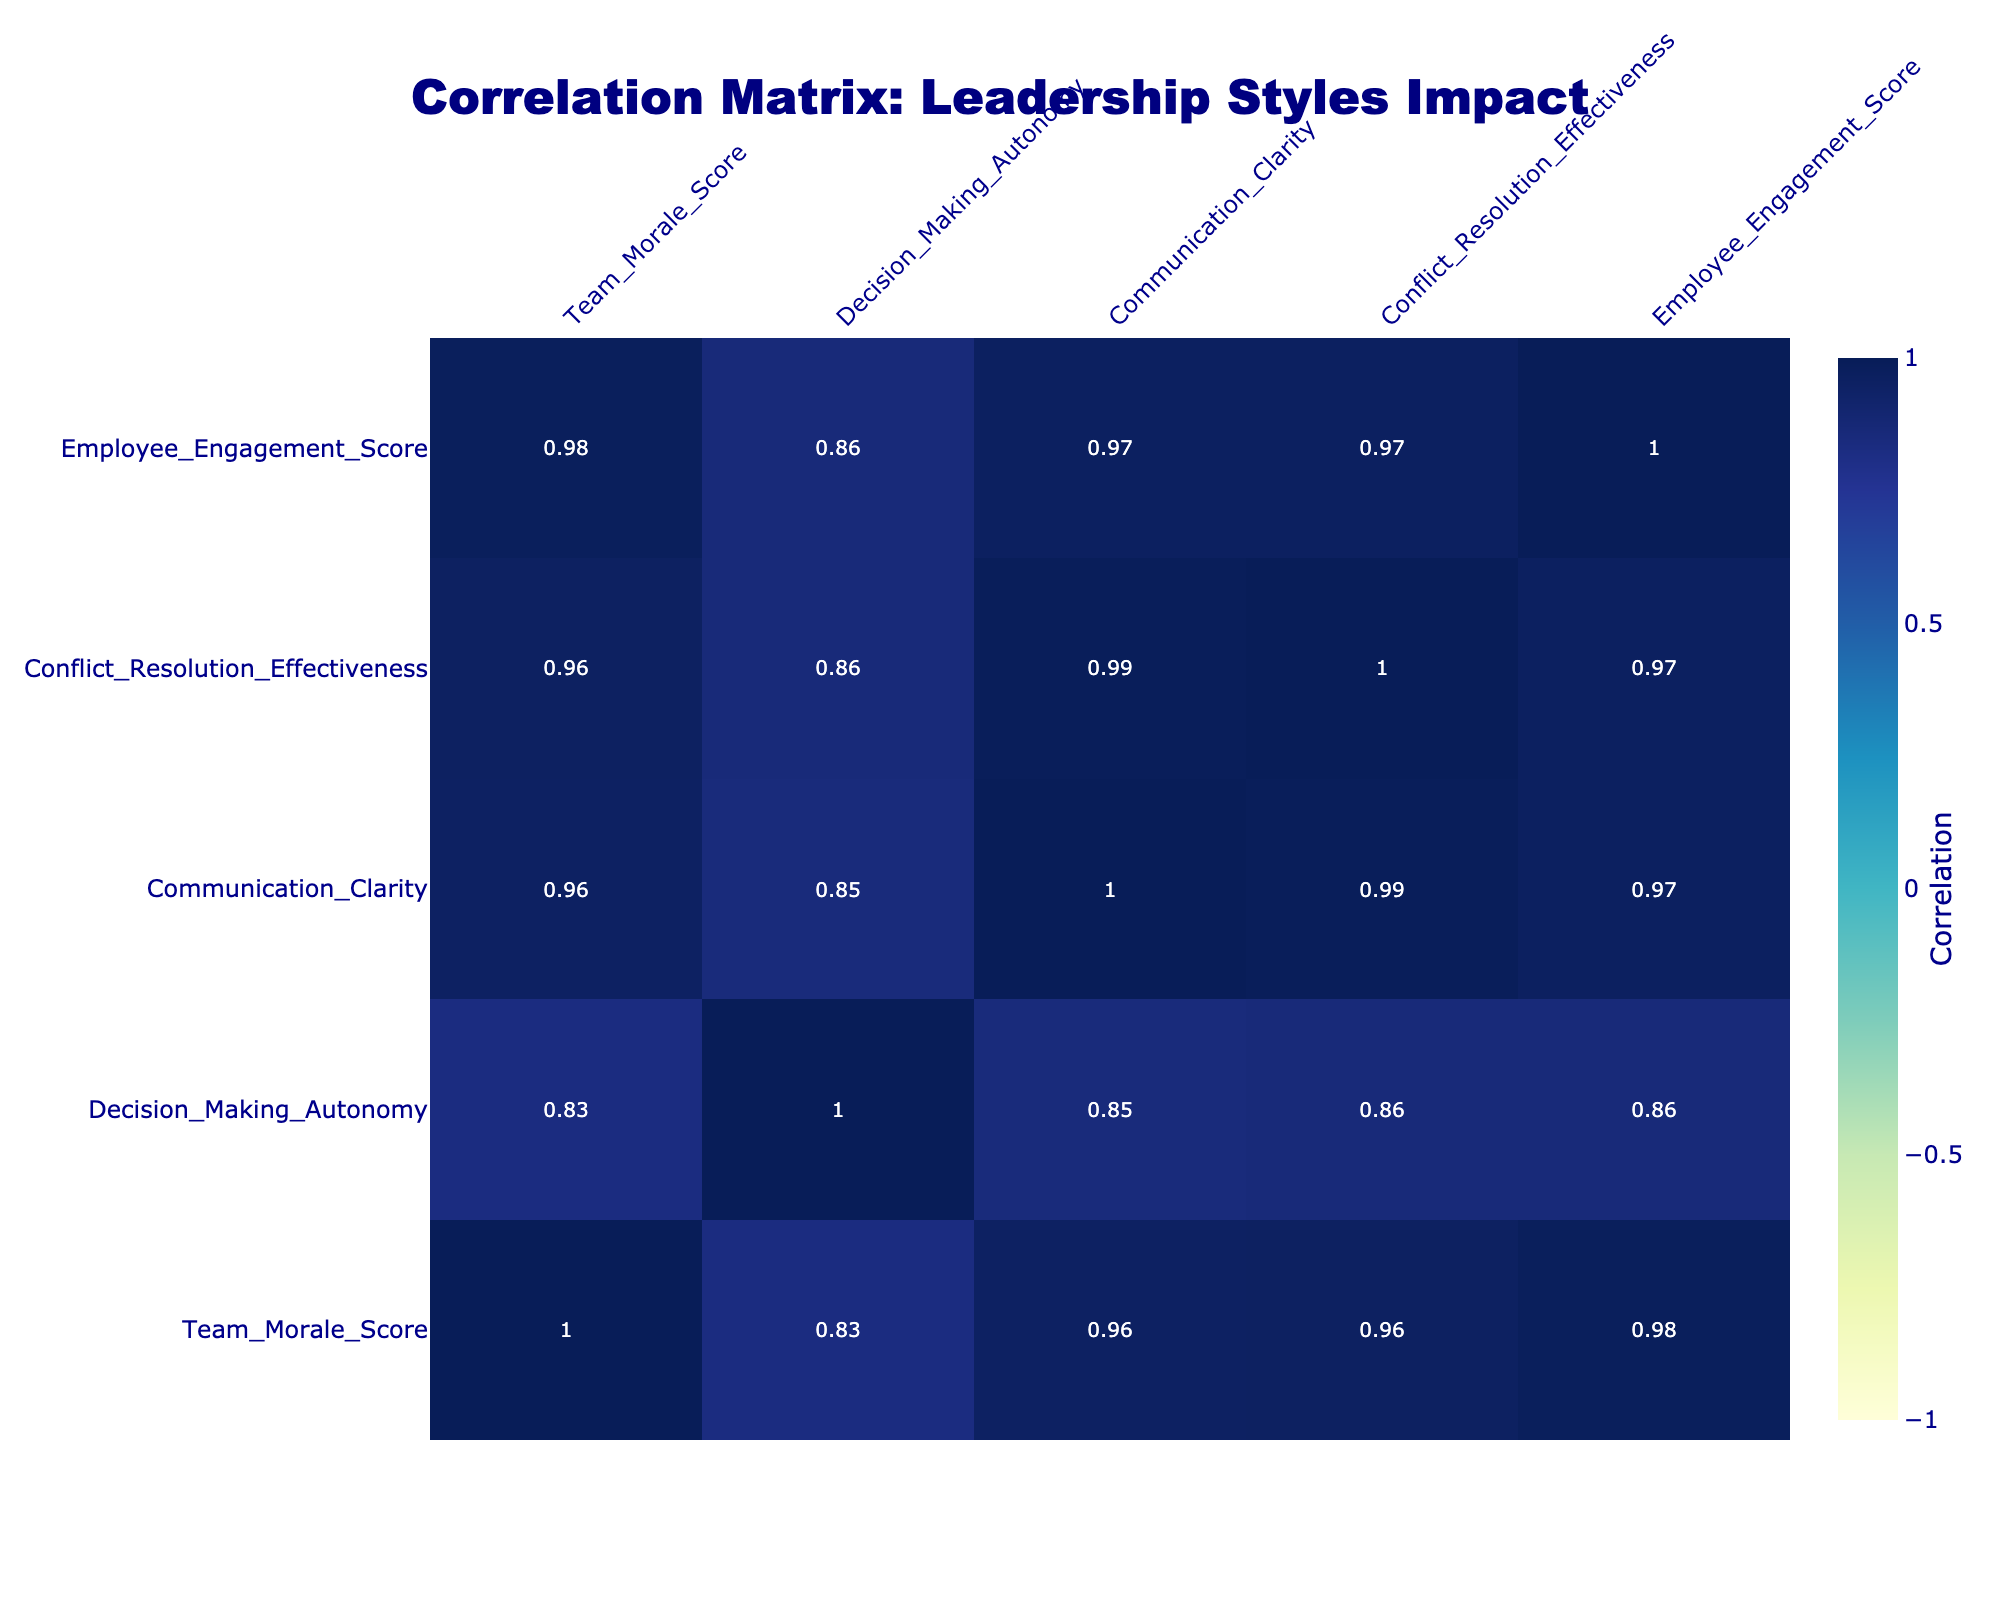What is the Team Morale Score for the Servant leadership style? The Team Morale Score directly corresponds to the "Servant" leadership style row in the table, which indicates a score of 92.
Answer: 92 Which leadership style has the highest Communication Clarity? By looking at the "Communication Clarity" column, the highest score is 95 associated with the "Servant" leadership style.
Answer: Servant What is the average Employee Engagement Score across all leadership styles? To find the average, sum all Employee Engagement Scores: (82 + 68 + 88 + 60 + 52 + 81 + 79 + 86 + 73 + 84) = 792, and there are 10 scores, so 792 / 10 = 79.2.
Answer: 79.2 Is the Team Morale Score for the Authoritarian leadership style greater than 60? The Team Morale Score for "Authoritarian" is 55, which is less than 60, so the answer is no.
Answer: No Which leadership style has the lowest Conflict Resolution Effectiveness score? Checking the "Conflict Resolution Effectiveness" column, the lowest score is 50, corresponding to the "Authoritarian" leadership style.
Answer: Authoritarian If we compare the Team Morale Scores of Transformational and Charismatic leadership styles, which one is higher? Transformational has a score of 85, while Charismatic has a score of 88. Upon comparing these values, Charismatic is higher than Transformational.
Answer: Charismatic How much higher is the Decision Making Autonomy score for Educational Leadership compared to the Laissez-Faire leadership style? The Decision Making Autonomy for "Educational Leadership" is 85 and for "Laissez-Faire" it is 70. The difference is 85 - 70 = 15.
Answer: 15 Is it true that all democratic styles have a Team Morale Score of 80 or above? "Democratic" has a score of 80, but "Laissez-Faire" has a score of 65, which is below 80, therefore not all democratic styles meet the criterion.
Answer: No What is the difference between the highest and lowest Employee Engagement Scores? The highest Employee Engagement Score is 88 (Servant), and the lowest is 52 (Authoritarian), so the difference is 88 - 52 = 36.
Answer: 36 